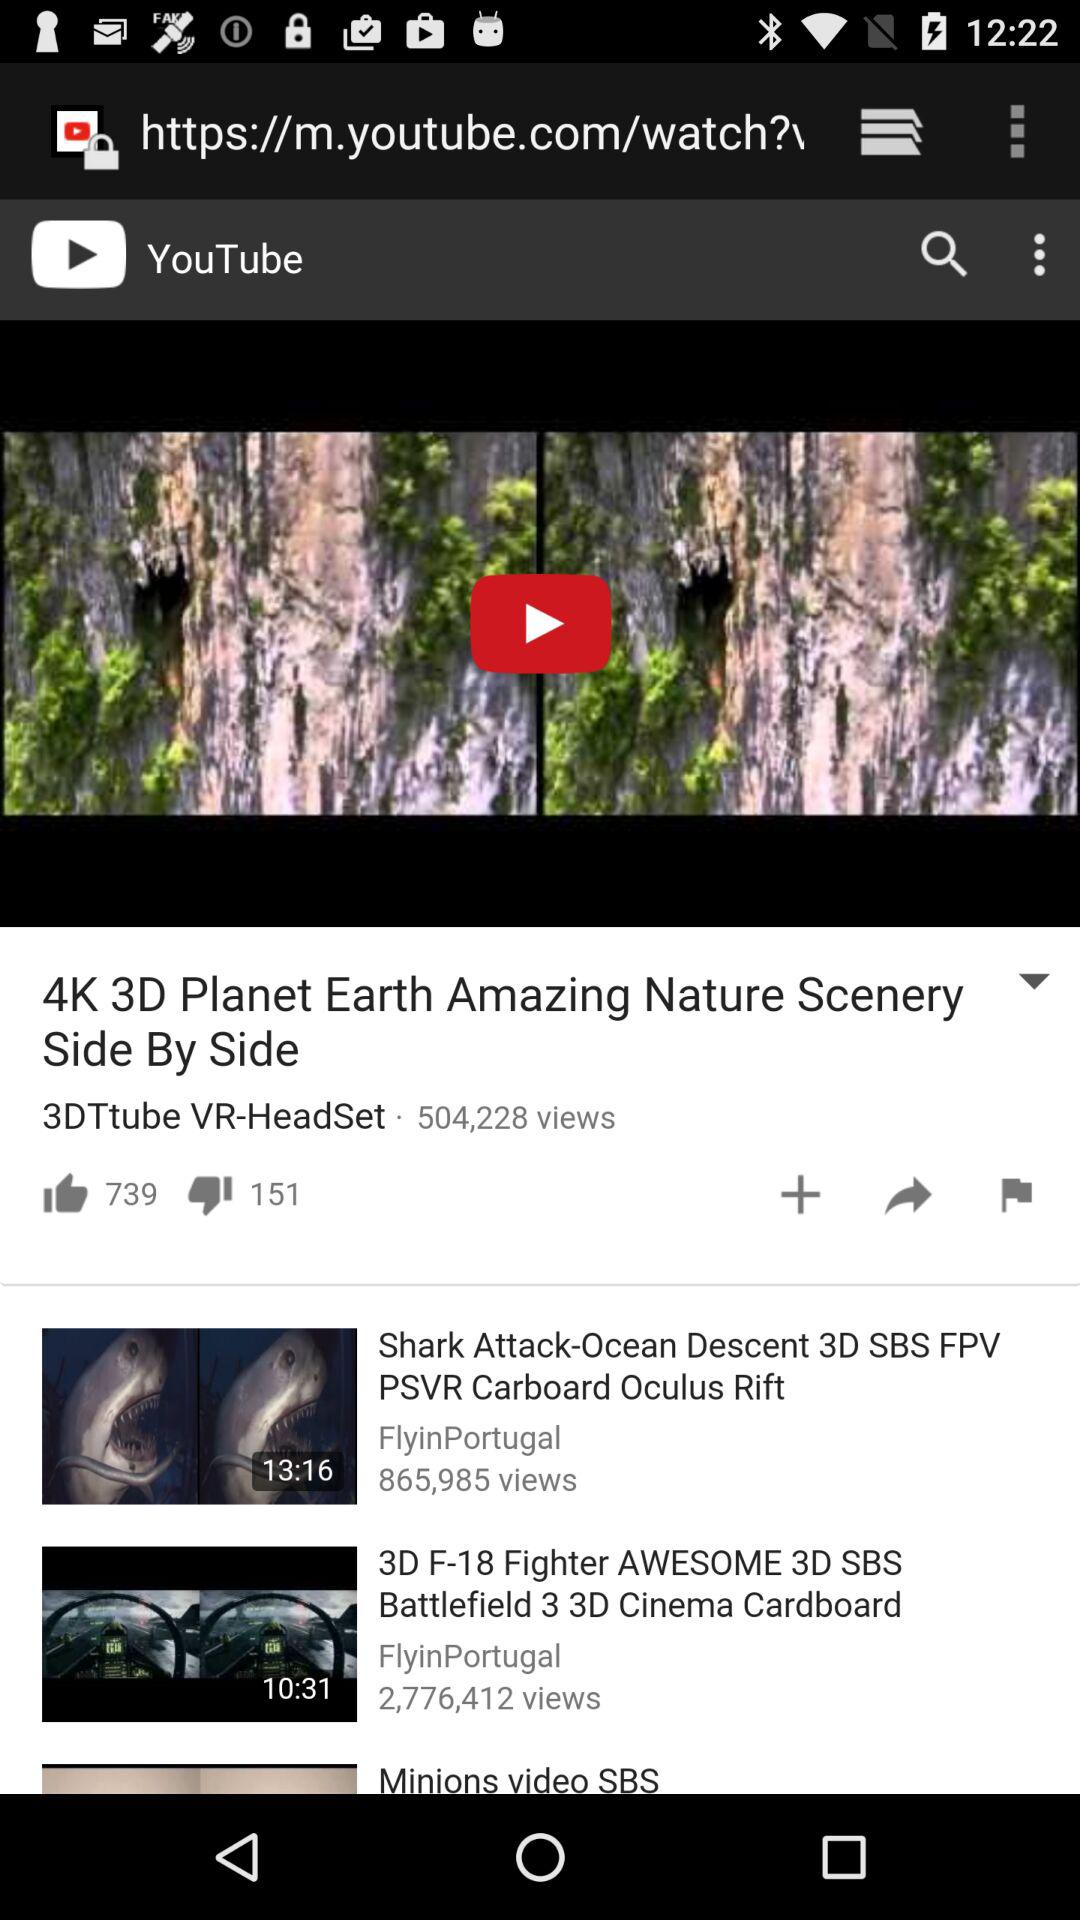What is the YouTube channel name that has 504,228 views? The YouTube channel name is "3DTtube VR-HeadSet". 